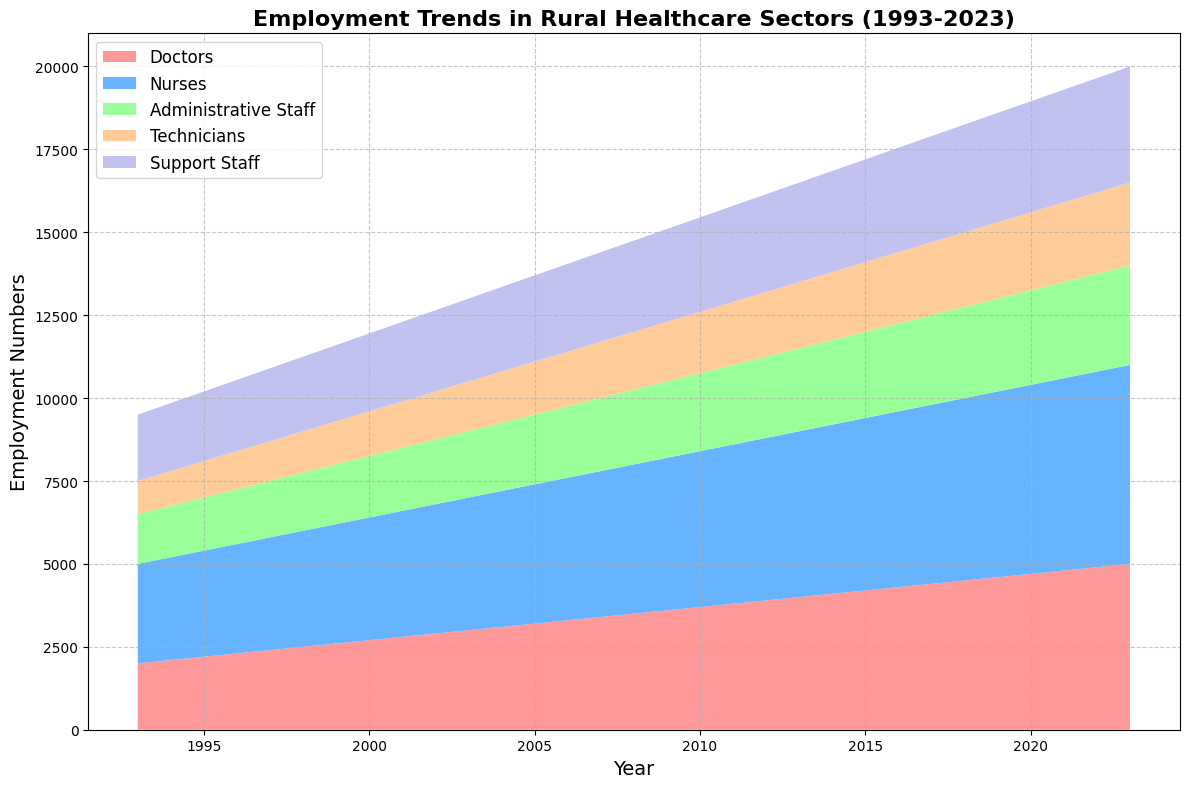What is the general trend in the number of doctors employed between 1993 and 2023? To determine the general trend, observe the line representing doctors in the area chart. The number of doctors increases steadily from 2000 in 1993 to 5000 in 2023, indicating consistent growth over the 30-year period.
Answer: Increasing Which occupation saw the highest number of employees in 2023? Look at the heights of the different-colored sections at the year 2023. The blue section, representing nurses, is the tallest, indicating the highest number of employees.
Answer: Nurses How much did the number of Administrative Staff increase from 1993 to 2023? Find the heights of the Administrative Staff in 1993 and 2023. In 1993, it is 1500, and in 2023, it is 3000. The increase is 3000 - 1500.
Answer: 1500 Which year did Nurses surpass 4000 employees? Trace the blue section representing nurses across the years. Identify the first year where the number exceeds 4000. It happens in the year 2004.
Answer: 2004 How does the number of Technicians in 2010 compare to the number of Support Staff in the same year? Look at the heights of the sections for Technicians and Support Staff in 2010. Technicians are at 1850, while Support Staff are at 2850, indicating that Support Staff are more in number.
Answer: Support Staff are more Calculate the total number of healthcare employees in 2000. Add the heights of all sections for the year 2000: 2700 (Doctors) + 3700 (Nurses) + 1850 (Administrative Staff) + 1350 (Technicians) + 2350 (Support Staff). The sum is 2700 + 3700 + 1850 + 1350 + 2350 = 11950.
Answer: 11950 Did the number of Support Staff ever surpass the number of Administrative Staff in any year shown? Compare the heights of the Support Staff section and Administrative Staff section year by year. Support Staff never surpasses the number of Administrative Staff in any given year.
Answer: No Which occupation type experienced the slowest growth rate over the 30 years period? Compare the starting and ending numbers for each occupation type. Administrative Staff started at 1500 in 1993 and grew to 3000 in 2023, doubling in 30 years. Other occupations show higher absolute growth. Therefore, Administrative Staff experienced the slowest growth rate.
Answer: Administrative Staff 